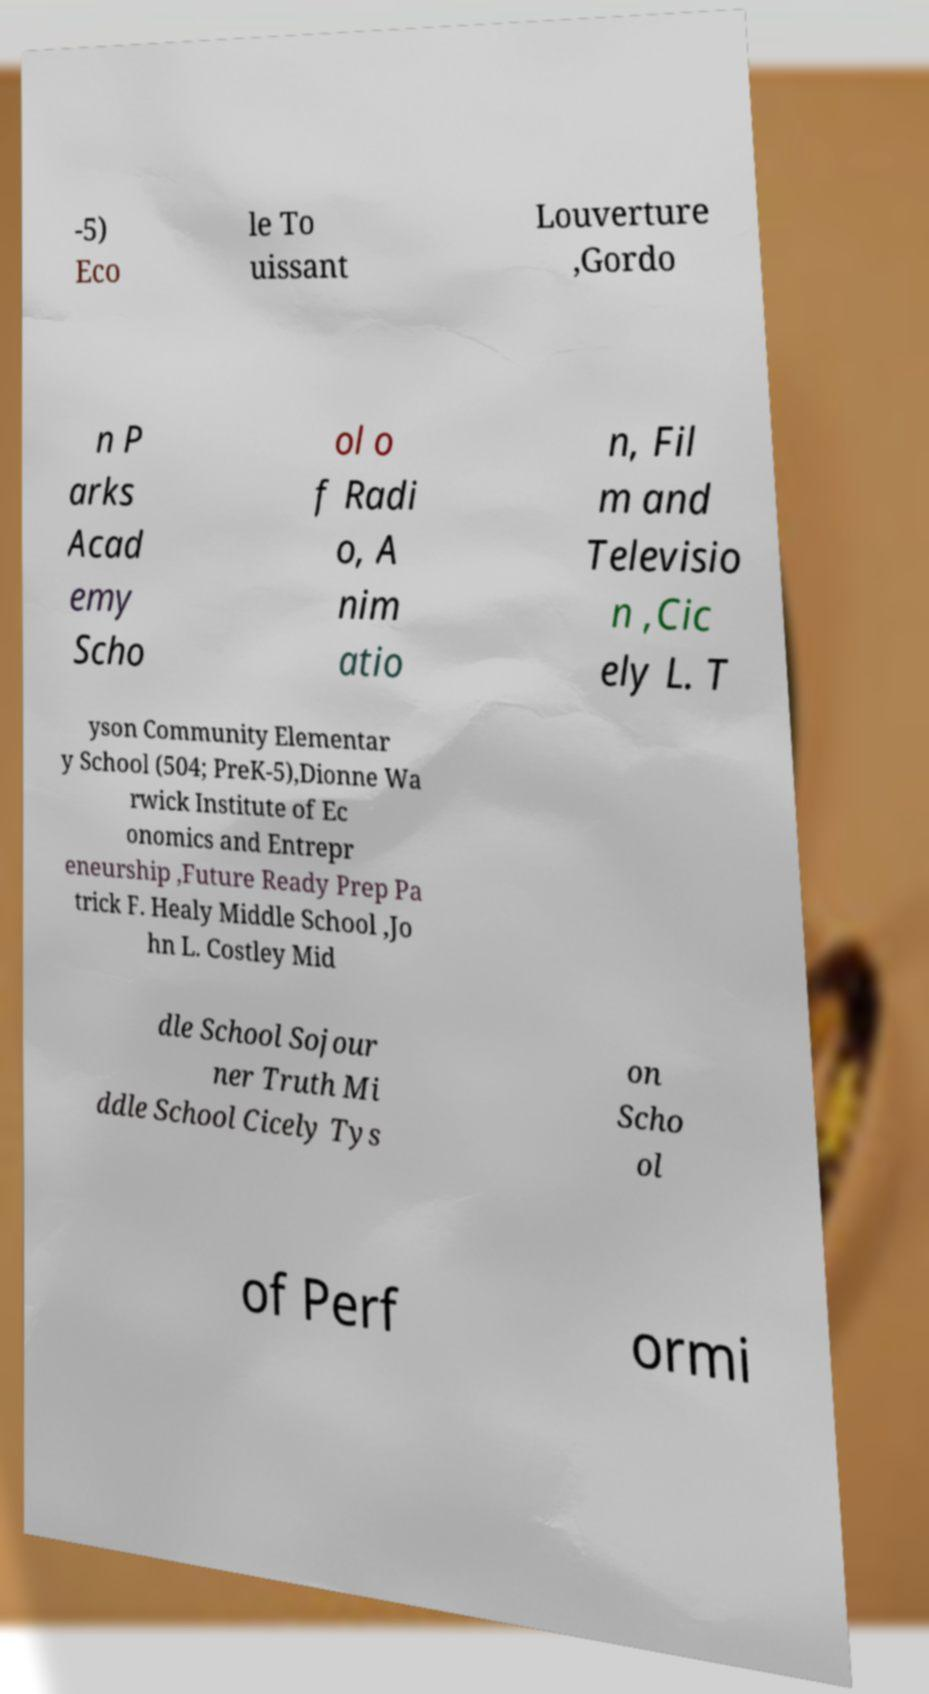What messages or text are displayed in this image? I need them in a readable, typed format. -5) Eco le To uissant Louverture ,Gordo n P arks Acad emy Scho ol o f Radi o, A nim atio n, Fil m and Televisio n ,Cic ely L. T yson Community Elementar y School (504; PreK-5),Dionne Wa rwick Institute of Ec onomics and Entrepr eneurship ,Future Ready Prep Pa trick F. Healy Middle School ,Jo hn L. Costley Mid dle School Sojour ner Truth Mi ddle School Cicely Tys on Scho ol of Perf ormi 